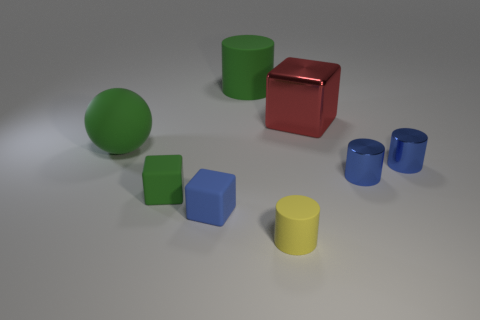Can you tell me about the lighting in this scene? The lighting in the scene seems to be coming from above, as indicated by the soft shadows located directly underneath the objects. The equal light distribution and lack of harsh shadows suggest the use of diffused lighting, which provides even illumination to the scene. 